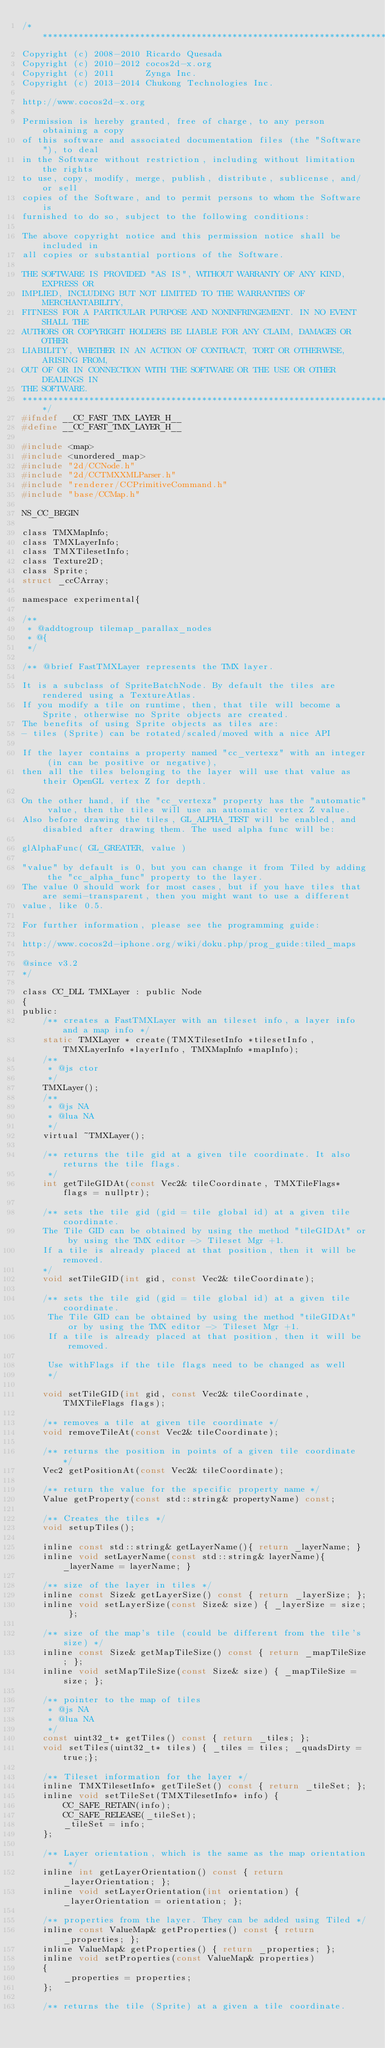Convert code to text. <code><loc_0><loc_0><loc_500><loc_500><_C_>/****************************************************************************
Copyright (c) 2008-2010 Ricardo Quesada
Copyright (c) 2010-2012 cocos2d-x.org
Copyright (c) 2011      Zynga Inc.
Copyright (c) 2013-2014 Chukong Technologies Inc.

http://www.cocos2d-x.org

Permission is hereby granted, free of charge, to any person obtaining a copy
of this software and associated documentation files (the "Software"), to deal
in the Software without restriction, including without limitation the rights
to use, copy, modify, merge, publish, distribute, sublicense, and/or sell
copies of the Software, and to permit persons to whom the Software is
furnished to do so, subject to the following conditions:

The above copyright notice and this permission notice shall be included in
all copies or substantial portions of the Software.

THE SOFTWARE IS PROVIDED "AS IS", WITHOUT WARRANTY OF ANY KIND, EXPRESS OR
IMPLIED, INCLUDING BUT NOT LIMITED TO THE WARRANTIES OF MERCHANTABILITY,
FITNESS FOR A PARTICULAR PURPOSE AND NONINFRINGEMENT. IN NO EVENT SHALL THE
AUTHORS OR COPYRIGHT HOLDERS BE LIABLE FOR ANY CLAIM, DAMAGES OR OTHER
LIABILITY, WHETHER IN AN ACTION OF CONTRACT, TORT OR OTHERWISE, ARISING FROM,
OUT OF OR IN CONNECTION WITH THE SOFTWARE OR THE USE OR OTHER DEALINGS IN
THE SOFTWARE.
****************************************************************************/
#ifndef __CC_FAST_TMX_LAYER_H__
#define __CC_FAST_TMX_LAYER_H__

#include <map>
#include <unordered_map>
#include "2d/CCNode.h"
#include "2d/CCTMXXMLParser.h"
#include "renderer/CCPrimitiveCommand.h"
#include "base/CCMap.h"

NS_CC_BEGIN

class TMXMapInfo;
class TMXLayerInfo;
class TMXTilesetInfo;
class Texture2D;
class Sprite;
struct _ccCArray;

namespace experimental{

/**
 * @addtogroup tilemap_parallax_nodes
 * @{
 */

/** @brief FastTMXLayer represents the TMX layer.

It is a subclass of SpriteBatchNode. By default the tiles are rendered using a TextureAtlas.
If you modify a tile on runtime, then, that tile will become a Sprite, otherwise no Sprite objects are created.
The benefits of using Sprite objects as tiles are:
- tiles (Sprite) can be rotated/scaled/moved with a nice API

If the layer contains a property named "cc_vertexz" with an integer (in can be positive or negative),
then all the tiles belonging to the layer will use that value as their OpenGL vertex Z for depth.

On the other hand, if the "cc_vertexz" property has the "automatic" value, then the tiles will use an automatic vertex Z value.
Also before drawing the tiles, GL_ALPHA_TEST will be enabled, and disabled after drawing them. The used alpha func will be:

glAlphaFunc( GL_GREATER, value )

"value" by default is 0, but you can change it from Tiled by adding the "cc_alpha_func" property to the layer.
The value 0 should work for most cases, but if you have tiles that are semi-transparent, then you might want to use a different
value, like 0.5.

For further information, please see the programming guide:

http://www.cocos2d-iphone.org/wiki/doku.php/prog_guide:tiled_maps

@since v3.2
*/

class CC_DLL TMXLayer : public Node
{
public:
    /** creates a FastTMXLayer with an tileset info, a layer info and a map info */
    static TMXLayer * create(TMXTilesetInfo *tilesetInfo, TMXLayerInfo *layerInfo, TMXMapInfo *mapInfo);
    /**
     * @js ctor
     */
    TMXLayer();
    /**
     * @js NA
     * @lua NA
     */
    virtual ~TMXLayer();

    /** returns the tile gid at a given tile coordinate. It also returns the tile flags.
     */
    int getTileGIDAt(const Vec2& tileCoordinate, TMXTileFlags* flags = nullptr);

    /** sets the tile gid (gid = tile global id) at a given tile coordinate.
    The Tile GID can be obtained by using the method "tileGIDAt" or by using the TMX editor -> Tileset Mgr +1.
    If a tile is already placed at that position, then it will be removed.
    */
    void setTileGID(int gid, const Vec2& tileCoordinate);

    /** sets the tile gid (gid = tile global id) at a given tile coordinate.
     The Tile GID can be obtained by using the method "tileGIDAt" or by using the TMX editor -> Tileset Mgr +1.
     If a tile is already placed at that position, then it will be removed.
     
     Use withFlags if the tile flags need to be changed as well
     */

    void setTileGID(int gid, const Vec2& tileCoordinate, TMXTileFlags flags);

    /** removes a tile at given tile coordinate */
    void removeTileAt(const Vec2& tileCoordinate);

    /** returns the position in points of a given tile coordinate */
    Vec2 getPositionAt(const Vec2& tileCoordinate);

    /** return the value for the specific property name */
    Value getProperty(const std::string& propertyName) const;

    /** Creates the tiles */
    void setupTiles();

    inline const std::string& getLayerName(){ return _layerName; }
    inline void setLayerName(const std::string& layerName){ _layerName = layerName; }

    /** size of the layer in tiles */
    inline const Size& getLayerSize() const { return _layerSize; };
    inline void setLayerSize(const Size& size) { _layerSize = size; };
    
    /** size of the map's tile (could be different from the tile's size) */
    inline const Size& getMapTileSize() const { return _mapTileSize; };
    inline void setMapTileSize(const Size& size) { _mapTileSize = size; };
    
    /** pointer to the map of tiles 
     * @js NA
     * @lua NA
     */
    const uint32_t* getTiles() const { return _tiles; };
    void setTiles(uint32_t* tiles) { _tiles = tiles; _quadsDirty = true;};
    
    /** Tileset information for the layer */
    inline TMXTilesetInfo* getTileSet() const { return _tileSet; };
    inline void setTileSet(TMXTilesetInfo* info) {
        CC_SAFE_RETAIN(info);
        CC_SAFE_RELEASE(_tileSet);
        _tileSet = info;
    };
    
    /** Layer orientation, which is the same as the map orientation */
    inline int getLayerOrientation() const { return _layerOrientation; };
    inline void setLayerOrientation(int orientation) { _layerOrientation = orientation; };
    
    /** properties from the layer. They can be added using Tiled */
    inline const ValueMap& getProperties() const { return _properties; };
    inline ValueMap& getProperties() { return _properties; };
    inline void setProperties(const ValueMap& properties)
    {
        _properties = properties;
    };

    /** returns the tile (Sprite) at a given a tile coordinate.</code> 